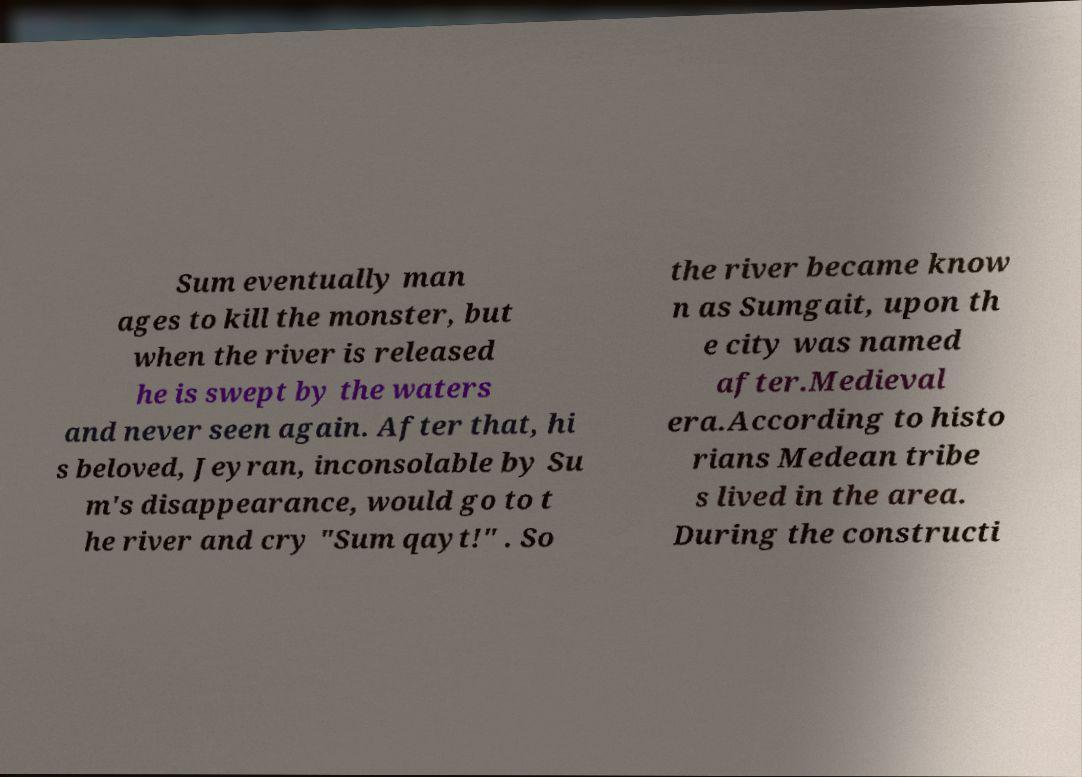I need the written content from this picture converted into text. Can you do that? Sum eventually man ages to kill the monster, but when the river is released he is swept by the waters and never seen again. After that, hi s beloved, Jeyran, inconsolable by Su m's disappearance, would go to t he river and cry "Sum qayt!" . So the river became know n as Sumgait, upon th e city was named after.Medieval era.According to histo rians Medean tribe s lived in the area. During the constructi 